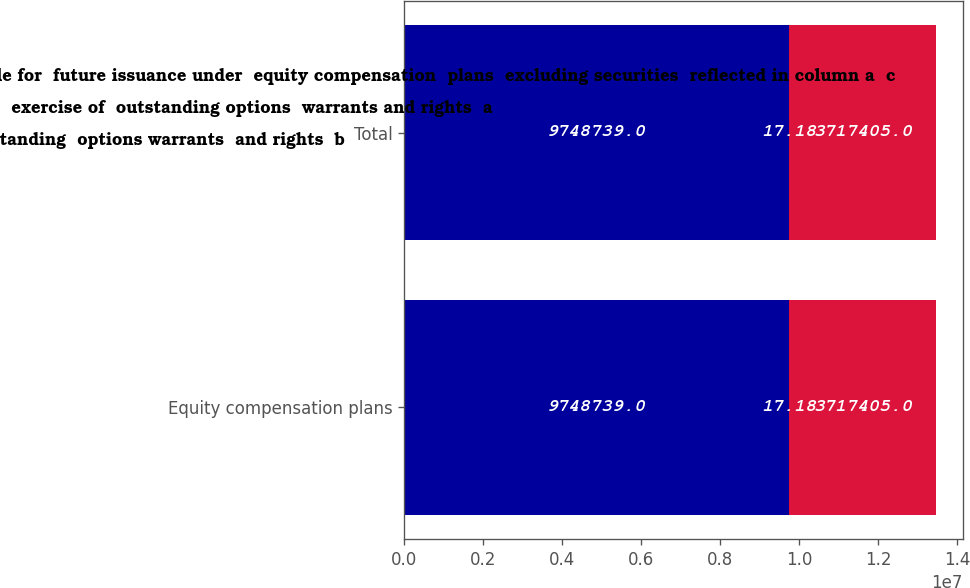Convert chart to OTSL. <chart><loc_0><loc_0><loc_500><loc_500><stacked_bar_chart><ecel><fcel>Equity compensation plans<fcel>Total<nl><fcel>Number of securities  remaining available for  future issuance under  equity compensation  plans  excluding securities  reflected in column a  c<fcel>9.74874e+06<fcel>9.74874e+06<nl><fcel>Number of  securities  to be issued upon  exercise of  outstanding options  warrants and rights  a<fcel>17.18<fcel>17.18<nl><fcel>Weightedaverage  exercise price of  outstanding  options warrants  and rights  b<fcel>3.7174e+06<fcel>3.7174e+06<nl></chart> 